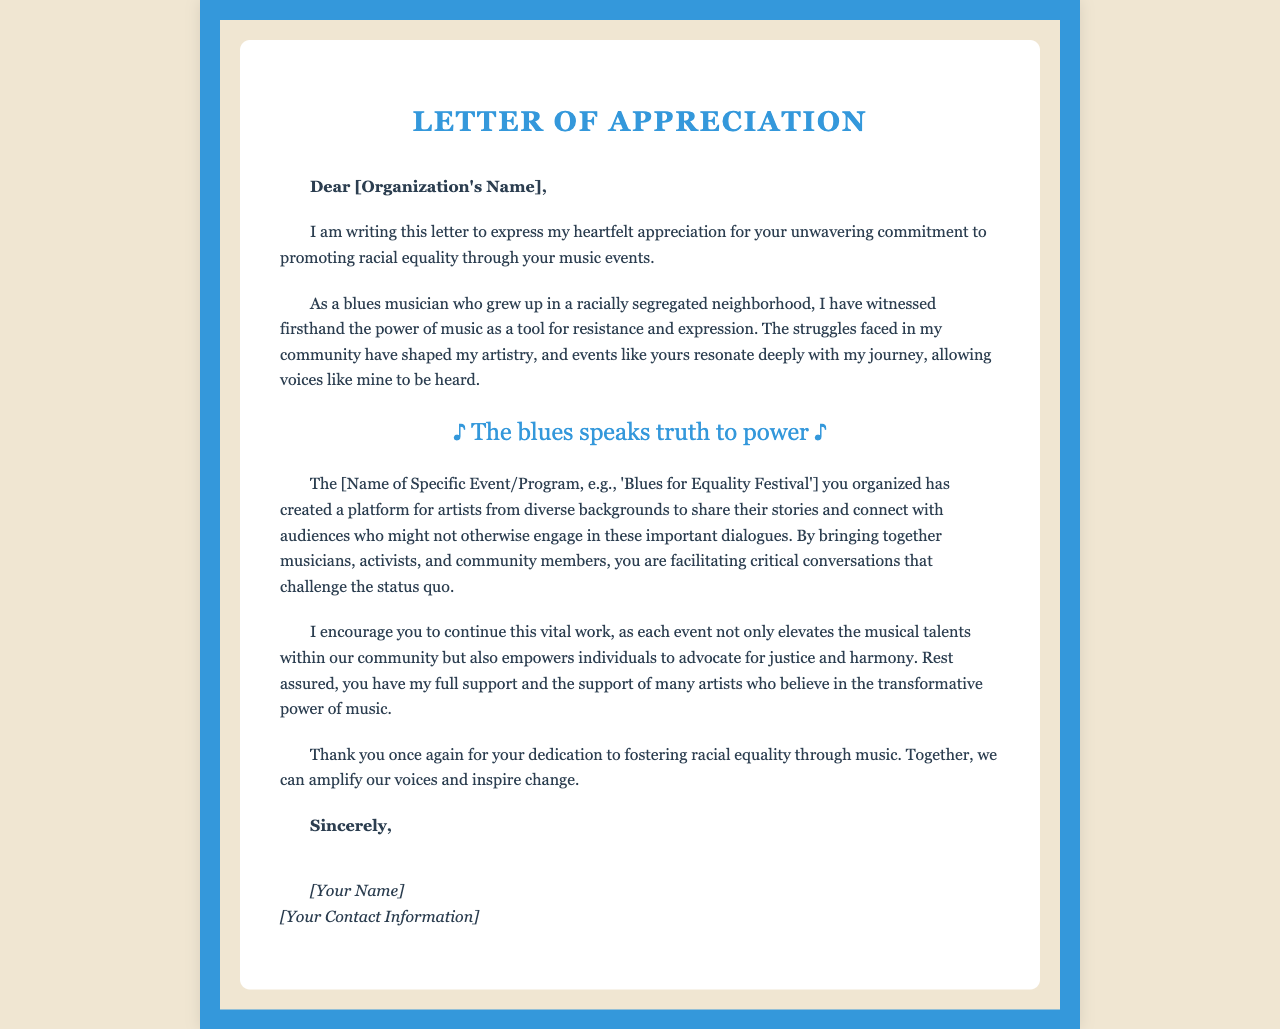what is the title of the letter? The title of the letter is found at the beginning of the document.
Answer: Letter of Appreciation who is the letter addressed to? The recipient's name is indicated in the greeting section of the document.
Answer: [Organization's Name] what event is mentioned in the letter? The letter references a specific event that emphasizes racial equality through music.
Answer: Blues for Equality Festival who is the author of the letter? The author concludes the letter with their signature, which identifies them.
Answer: [Your Name] what phrase highlights the power of music referenced in the letter? A notable phrase in the letter points to music speaking truth to power.
Answer: The blues speaks truth to power how does the author describe their background? The author provides context about their upbringing in the letter.
Answer: grew up in a racially segregated neighborhood what is the purpose of the letter? The letter serves to express appreciation for the organization's efforts in a specific area.
Answer: promoting racial equality through music events what does the author encourage the organization to do? The author suggests a course of action for the organization to continue their efforts.
Answer: continue this vital work how does the author express support for the organization? The author's support is conveyed through a specific phrase in the letter.
Answer: you have my full support 